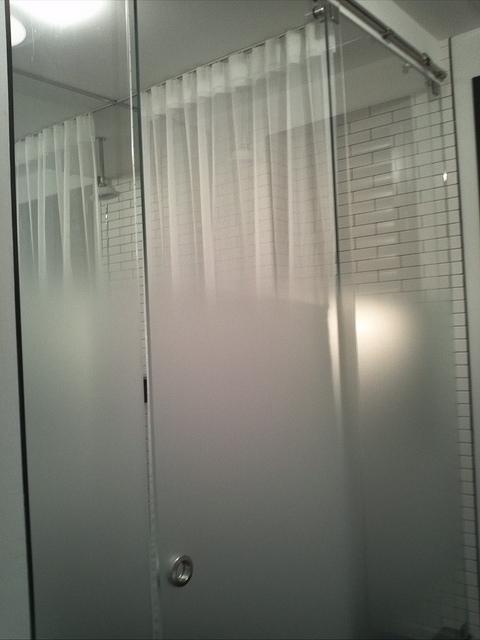Are the curtains checkered?
Keep it brief. No. What type of tiling is visible in this picture?
Quick response, please. Brick. Is this a living room?
Short answer required. No. What color are the curtains?
Give a very brief answer. White. 